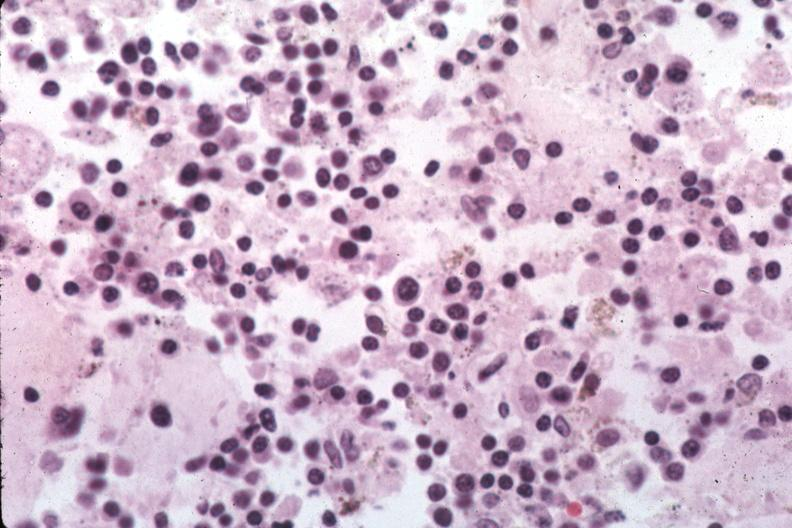what are easily evident?
Answer the question using a single word or phrase. Organisms 